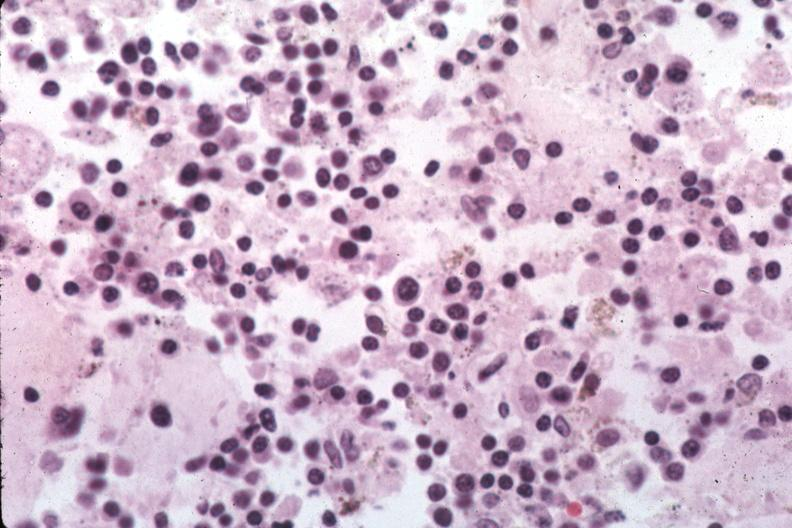what are easily evident?
Answer the question using a single word or phrase. Organisms 